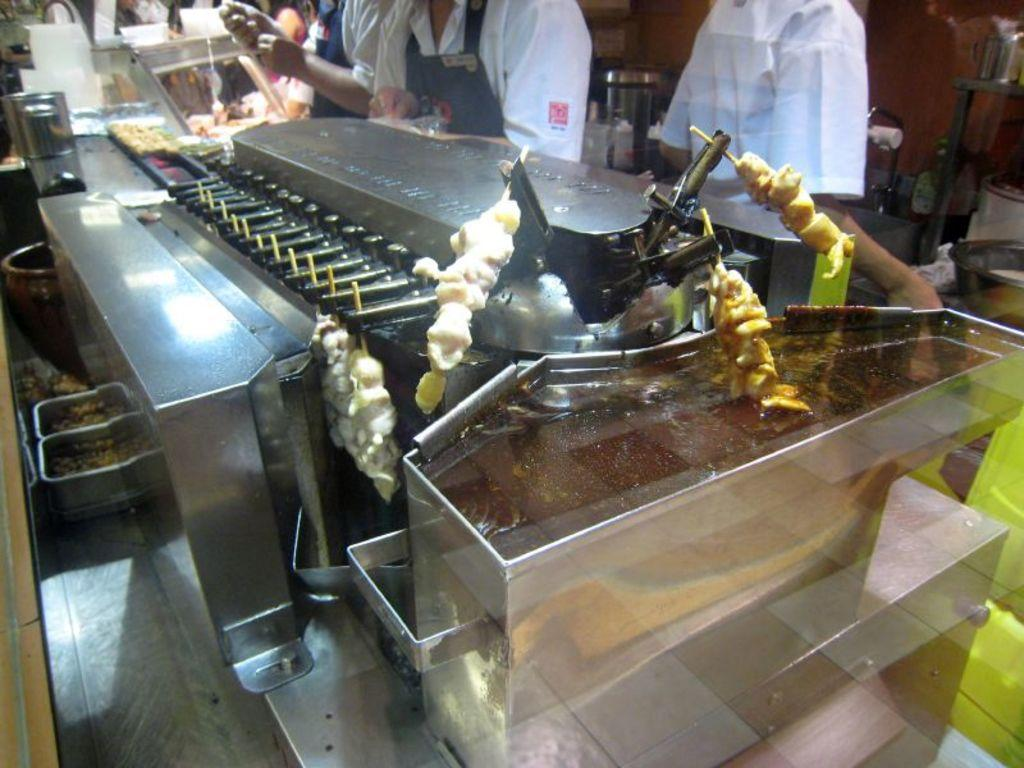What type of cooking appliances are visible in the image? There are grill machines in the image. What type of food is being prepared on the grill machines? There is food on sticks in the image. Who is present near the grill machines? There are people standing near the grill machines. What can be seen on the floor to the left of the grill machines? There are vessels on the floor to the left of the grill machines. What type of beginner's club is being advertised in the image? There is no mention of a beginner's club or any advertisement in the image; it features grill machines and related items. 